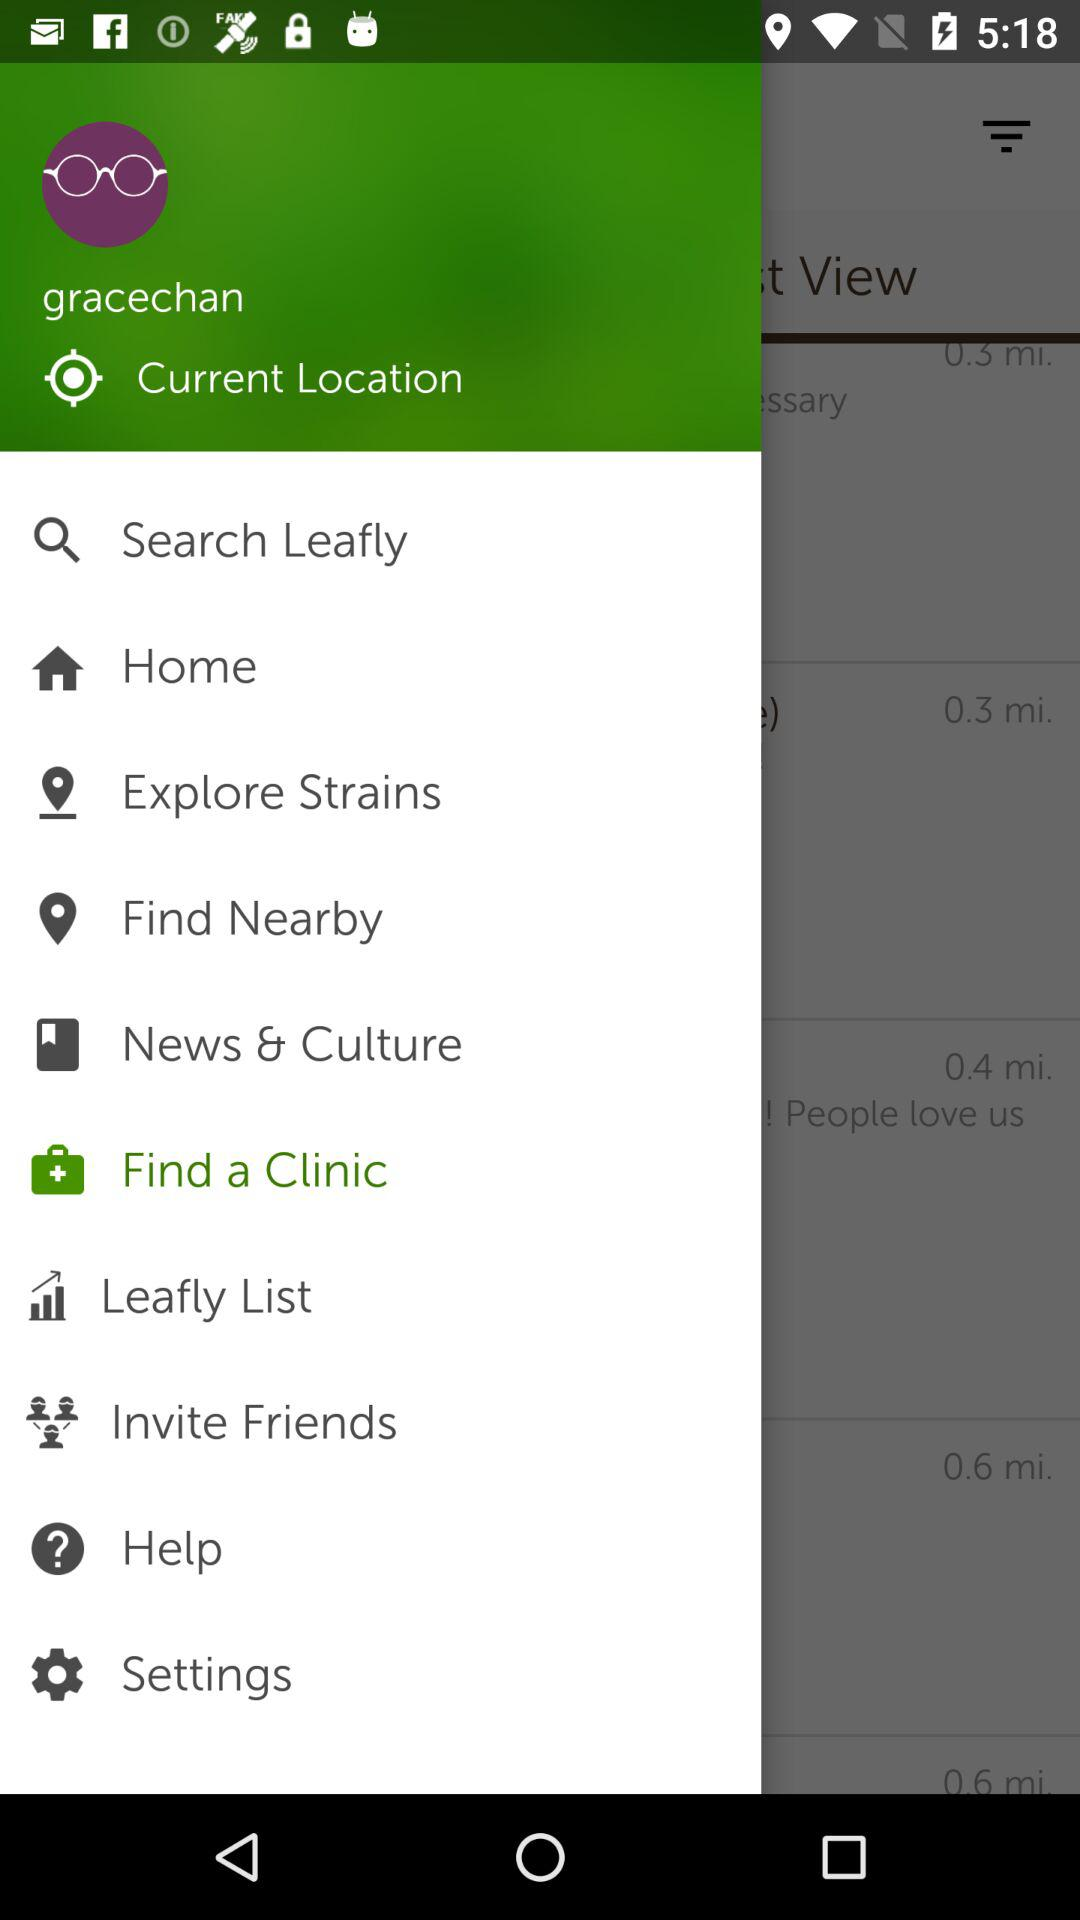Which is the selected option? The selected option is "Find a Clinic". 